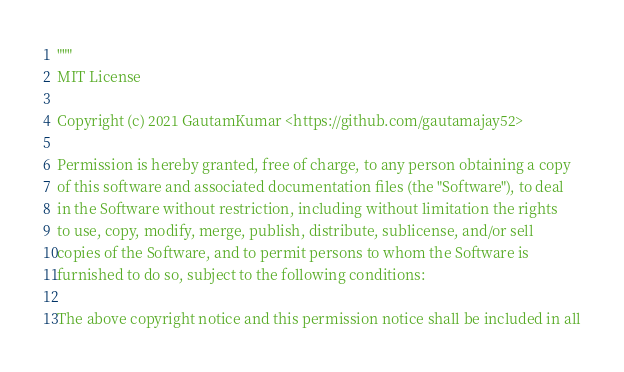<code> <loc_0><loc_0><loc_500><loc_500><_Python_>"""
MIT License

Copyright (c) 2021 GautamKumar <https://github.com/gautamajay52>

Permission is hereby granted, free of charge, to any person obtaining a copy
of this software and associated documentation files (the "Software"), to deal
in the Software without restriction, including without limitation the rights
to use, copy, modify, merge, publish, distribute, sublicense, and/or sell
copies of the Software, and to permit persons to whom the Software is
furnished to do so, subject to the following conditions:

The above copyright notice and this permission notice shall be included in all</code> 